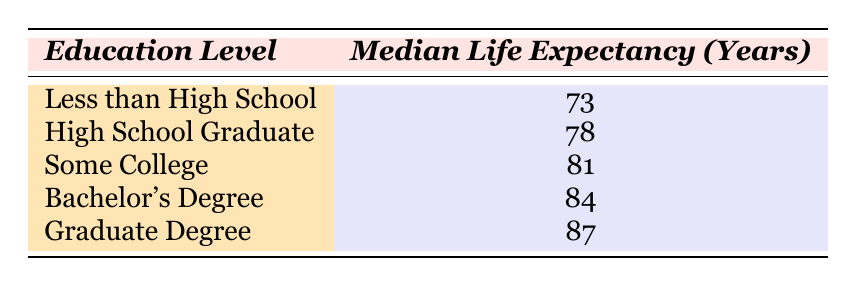What is the median life expectancy for women with a Bachelor's Degree? The table provides the median life expectancy for women with a Bachelor's Degree, which is directly listed as 84 years.
Answer: 84 How many years longer do women with a Graduate Degree live compared to those with less than High School education? From the table, the median life expectancy for women with a Graduate Degree is 87 years and for those with less than High School it is 73 years. The difference is calculated as 87 - 73 = 14 years.
Answer: 14 Is it true that women with Some College education have a median life expectancy of 81 years? The table states that the median life expectancy for women with Some College education is indeed 81 years.
Answer: Yes Which education level corresponds to the lowest median life expectancy? Looking at the table, the education level with the lowest median life expectancy is "Less than High School," which shows 73 years.
Answer: Less than High School What is the average median life expectancy for women with a High School Graduate and a Bachelor’s Degree? The median life expectancy for a High School Graduate is 78 years and for a Bachelor's Degree is 84 years. To find the average, we sum these values (78 + 84) = 162, and divide by 2, resulting in an average of 81 years.
Answer: 81 How much does the median life expectancy increase from High School Graduate to Graduate Degree? The table shows a median life expectancy of 78 years for High School Graduates and 87 years for Graduate Degrees. The increase is calculated as 87 - 78 = 9 years.
Answer: 9 Is the median life expectancy for women with a Bachelor's Degree higher than those with Some College education? According to the table, the median life expectancy for women with a Bachelor's Degree is 84 years, while for Some College education it is 81 years. Since 84 is greater than 81, the statement is true.
Answer: Yes What is the median life expectancy difference between women with a Graduate Degree and those with a High School Graduate? Women with a Graduate Degree have a life expectancy of 87 years and those with a High School Graduate have 78 years. The difference is 87 - 78 = 9 years of life expectancy.
Answer: 9 Which region is represented in this table, and does it mention access to comprehensive healthcare? The table specifies the region as the Southern US. In the description of women with a Graduate Degree, it indicates that they often live the longest due to high socioeconomic status and access to comprehensive healthcare.
Answer: Southern US; Yes 